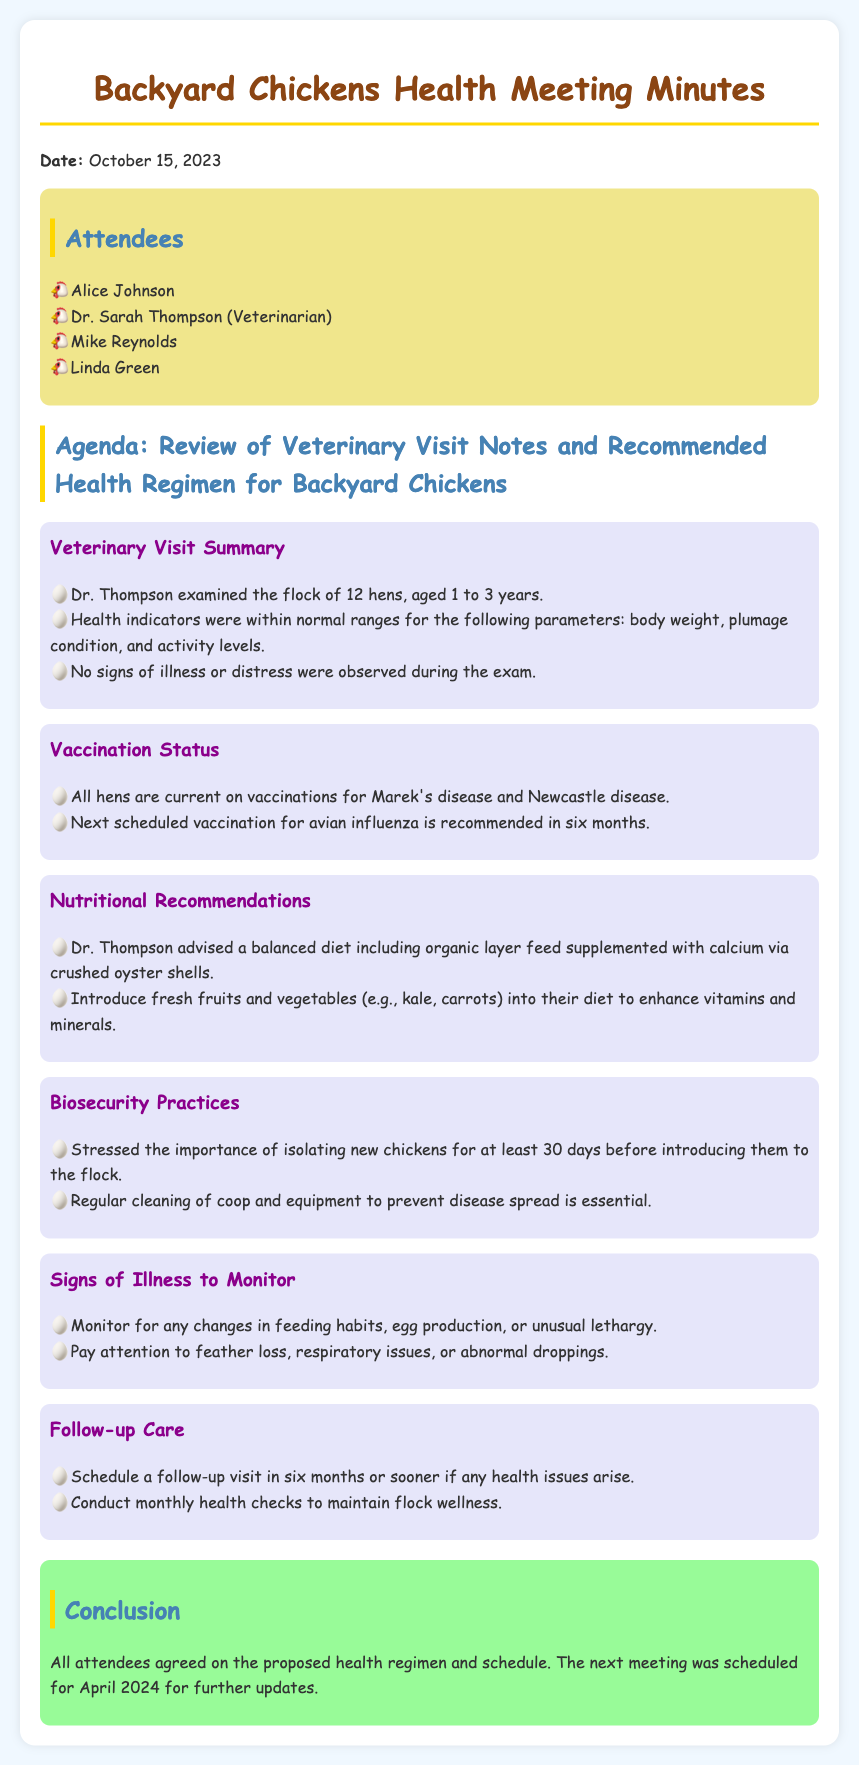What is the date of the meeting? The date of the meeting is mentioned at the beginning, which is October 15, 2023.
Answer: October 15, 2023 Who examined the flock? The veterinarian who examined the flock is Dr. Sarah Thompson, as noted in the veterinary visit summary.
Answer: Dr. Sarah Thompson How many hens were examined? The document states that a flock of 12 hens was examined during the veterinary visit.
Answer: 12 hens What is the recommended interval for the next vaccination? The next scheduled vaccination for avian influenza is recommended in six months, as per the vaccination status summary.
Answer: six months What is one of the nutritional recommendations? One of the nutritional recommendations includes a balanced diet with organic layer feed and calcium via crushed oyster shells, as outlined under nutritional recommendations.
Answer: organic layer feed What is a sign of illness to monitor? The document lists changes in feeding habits as a sign of illness to monitor under signs of illness to monitor.
Answer: changes in feeding habits What is the follow-up care timeframe? The follow-up visit is scheduled in six months or sooner if health issues arise, according to the follow-up care section.
Answer: six months What is the next meeting date scheduled for? The next meeting is scheduled for April 2024, as mentioned in the conclusion section.
Answer: April 2024 